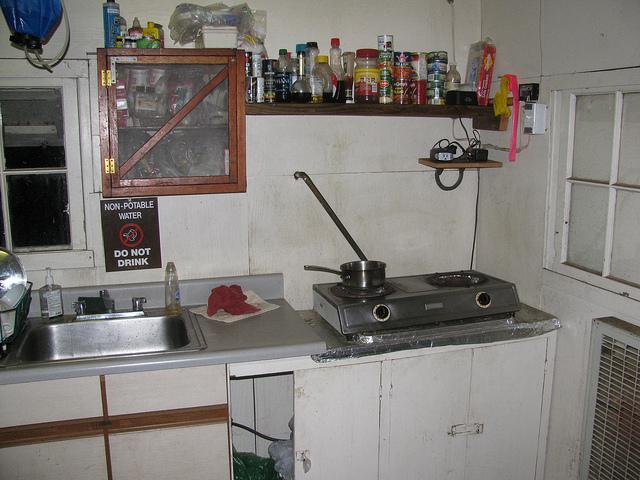Is this a clean kitchen?
Concise answer only. No. Could this bottle be of Shiner beer?
Keep it brief. No. Are there any pots on the stove?
Quick response, please. Yes. There are 13 knives hanging up. Yes the tomatoes are in a zip lock bag?
Short answer required. No. What is on the shelf?
Give a very brief answer. Food. What is on the stove?
Write a very short answer. Pot. Are there any cabinet doors missing?
Quick response, please. Yes. How many burners?
Be succinct. 2. How many burners are on the stove?
Write a very short answer. 2. What color are the shelves?
Concise answer only. Brown. Is there an old kettle on the stove?
Give a very brief answer. No. Is this a bathroom?
Be succinct. No. Where are the pans?
Keep it brief. Stove. What does the sign over the stove say?
Concise answer only. Non-potable water do not drink. Are the pots being used?
Write a very short answer. Yes. Should you drink the sink water?
Write a very short answer. No. 